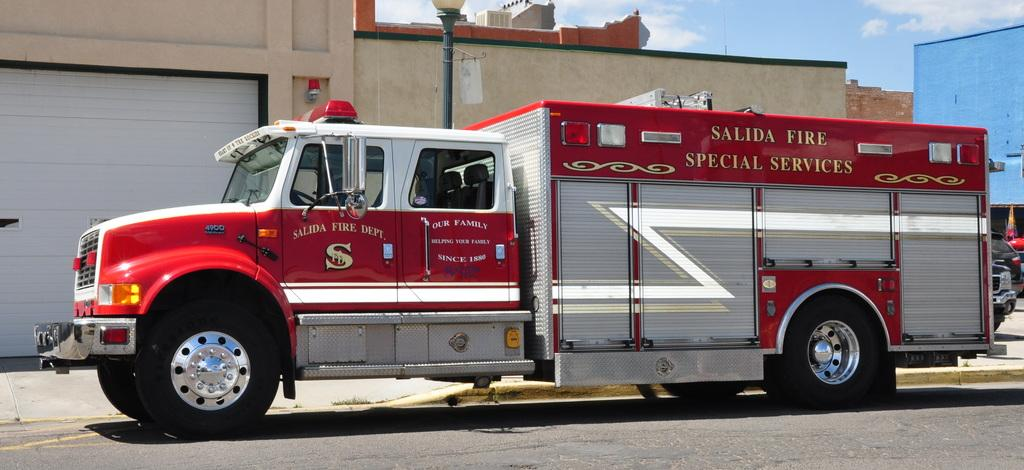What types of vehicles are on the ground in the image? The image shows vehicles on the ground, but the specific types cannot be determined from the provided facts. What structures can be seen in the image? There are buildings visible in the image. What is attached to the electric pole in the image? The electric pole has a light attached to it. What else is present in the image besides vehicles and buildings? There are objects present in the image, but their nature cannot be determined from the provided facts. What is visible in the background of the image? The sky is visible in the background of the image. What can be seen in the sky? Clouds are present in the sky. Where is the card located in the image? There is no card present in the image. Can you tell me how many basketballs are visible in the image? There are no basketballs present in the image. 